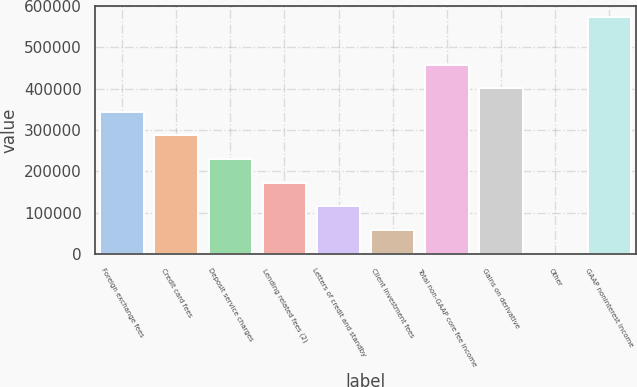Convert chart to OTSL. <chart><loc_0><loc_0><loc_500><loc_500><bar_chart><fcel>Foreign exchange fees<fcel>Credit card fees<fcel>Deposit service charges<fcel>Lending related fees (2)<fcel>Letters of credit and standby<fcel>Client investment fees<fcel>Total non-GAAP core fee income<fcel>Gains on derivative<fcel>Other<fcel>GAAP noninterest income<nl><fcel>343847<fcel>286750<fcel>229652<fcel>172554<fcel>115456<fcel>58357.9<fcel>458043<fcel>400945<fcel>1260<fcel>572239<nl></chart> 